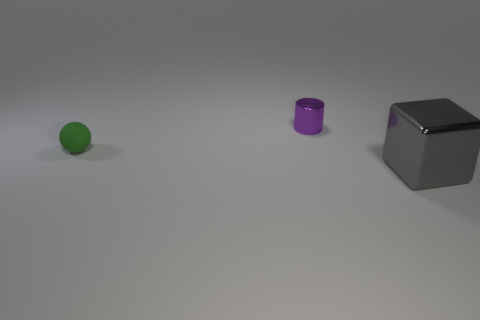Subtract all cylinders. How many objects are left? 2 Add 1 big yellow spheres. How many objects exist? 4 Subtract 1 gray cubes. How many objects are left? 2 Subtract all blue cylinders. Subtract all purple blocks. How many cylinders are left? 1 Subtract all purple cylinders. How many purple cubes are left? 0 Subtract all matte cubes. Subtract all shiny objects. How many objects are left? 1 Add 2 tiny green matte balls. How many tiny green matte balls are left? 3 Add 2 small blue rubber things. How many small blue rubber things exist? 2 